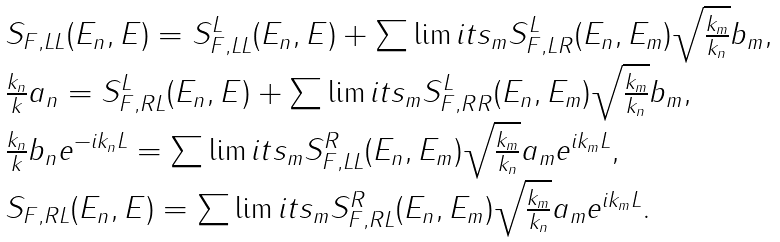<formula> <loc_0><loc_0><loc_500><loc_500>\begin{array} { l } S _ { F , L L } ( E _ { n } , E ) = S ^ { L } _ { F , L L } ( E _ { n } , E ) + \sum \lim i t s _ { m } S ^ { L } _ { F , L R } ( E _ { n } , E _ { m } ) \sqrt { \frac { k _ { m } } { k _ { n } } } b _ { m } , \\ \frac { k _ { n } } { k } a _ { n } = S ^ { L } _ { F , R L } ( E _ { n } , E ) + \sum \lim i t s _ { m } S ^ { L } _ { F , R R } ( E _ { n } , E _ { m } ) \sqrt { \frac { k _ { m } } { k _ { n } } } b _ { m } , \\ \frac { k _ { n } } { k } b _ { n } e ^ { - i k _ { n } L } = \sum \lim i t s _ { m } S ^ { R } _ { F , L L } ( E _ { n } , E _ { m } ) \sqrt { \frac { k _ { m } } { k _ { n } } } a _ { m } e ^ { i k _ { m } L } , \\ S _ { F , R L } ( E _ { n } , E ) = \sum \lim i t s _ { m } S ^ { R } _ { F , R L } ( E _ { n } , E _ { m } ) \sqrt { \frac { k _ { m } } { k _ { n } } } a _ { m } e ^ { i k _ { m } L } . \end{array}</formula> 